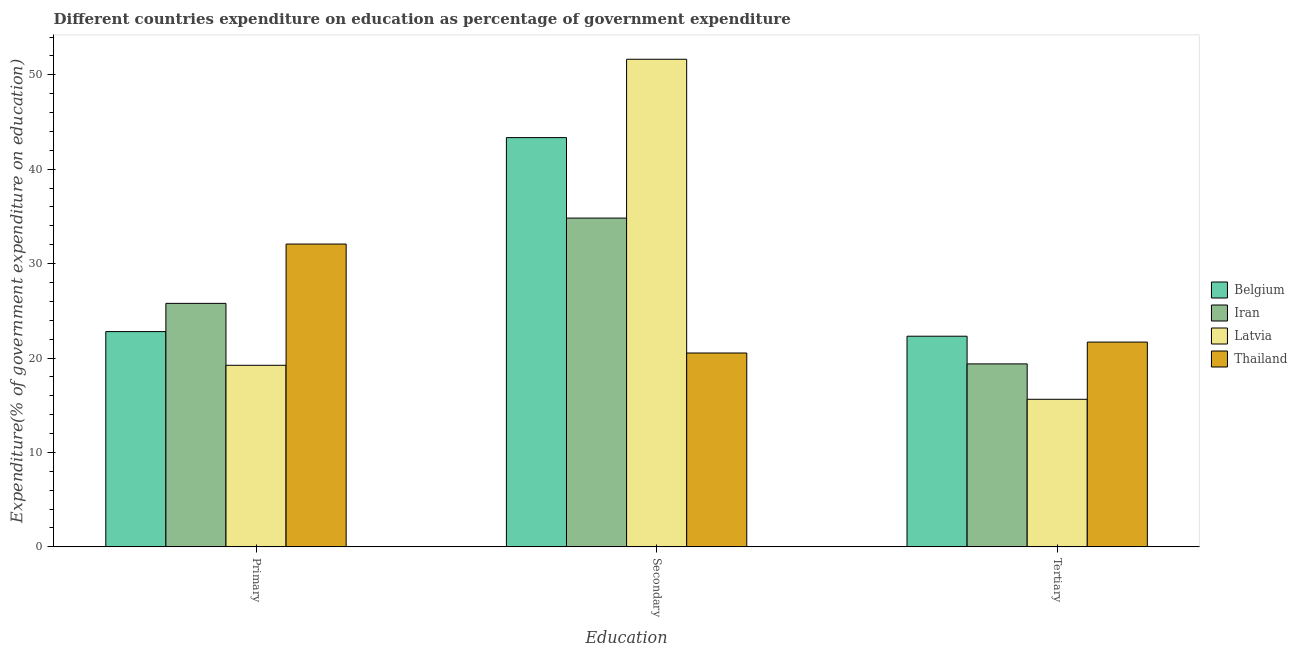How many different coloured bars are there?
Provide a short and direct response. 4. Are the number of bars on each tick of the X-axis equal?
Your answer should be compact. Yes. How many bars are there on the 2nd tick from the left?
Give a very brief answer. 4. How many bars are there on the 2nd tick from the right?
Your answer should be very brief. 4. What is the label of the 2nd group of bars from the left?
Give a very brief answer. Secondary. What is the expenditure on secondary education in Latvia?
Ensure brevity in your answer.  51.64. Across all countries, what is the maximum expenditure on tertiary education?
Provide a succinct answer. 22.31. Across all countries, what is the minimum expenditure on secondary education?
Your answer should be very brief. 20.53. In which country was the expenditure on secondary education maximum?
Give a very brief answer. Latvia. In which country was the expenditure on secondary education minimum?
Your answer should be compact. Thailand. What is the total expenditure on secondary education in the graph?
Ensure brevity in your answer.  150.34. What is the difference between the expenditure on secondary education in Latvia and that in Thailand?
Your answer should be compact. 31.11. What is the difference between the expenditure on tertiary education in Belgium and the expenditure on primary education in Iran?
Keep it short and to the point. -3.48. What is the average expenditure on primary education per country?
Provide a short and direct response. 24.97. What is the difference between the expenditure on tertiary education and expenditure on primary education in Iran?
Provide a short and direct response. -6.41. What is the ratio of the expenditure on primary education in Latvia to that in Thailand?
Provide a succinct answer. 0.6. Is the expenditure on tertiary education in Belgium less than that in Iran?
Give a very brief answer. No. What is the difference between the highest and the second highest expenditure on primary education?
Ensure brevity in your answer.  6.28. What is the difference between the highest and the lowest expenditure on primary education?
Make the answer very short. 12.84. Is the sum of the expenditure on primary education in Latvia and Belgium greater than the maximum expenditure on secondary education across all countries?
Your answer should be compact. No. What does the 3rd bar from the left in Secondary represents?
Provide a short and direct response. Latvia. What does the 1st bar from the right in Secondary represents?
Give a very brief answer. Thailand. How many bars are there?
Provide a succinct answer. 12. How many countries are there in the graph?
Keep it short and to the point. 4. What is the difference between two consecutive major ticks on the Y-axis?
Make the answer very short. 10. Are the values on the major ticks of Y-axis written in scientific E-notation?
Ensure brevity in your answer.  No. Does the graph contain any zero values?
Offer a very short reply. No. Does the graph contain grids?
Keep it short and to the point. No. How many legend labels are there?
Ensure brevity in your answer.  4. How are the legend labels stacked?
Your answer should be compact. Vertical. What is the title of the graph?
Your response must be concise. Different countries expenditure on education as percentage of government expenditure. Does "Costa Rica" appear as one of the legend labels in the graph?
Keep it short and to the point. No. What is the label or title of the X-axis?
Your answer should be very brief. Education. What is the label or title of the Y-axis?
Your response must be concise. Expenditure(% of government expenditure on education). What is the Expenditure(% of government expenditure on education) in Belgium in Primary?
Offer a terse response. 22.8. What is the Expenditure(% of government expenditure on education) of Iran in Primary?
Ensure brevity in your answer.  25.79. What is the Expenditure(% of government expenditure on education) in Latvia in Primary?
Your answer should be compact. 19.23. What is the Expenditure(% of government expenditure on education) in Thailand in Primary?
Your answer should be very brief. 32.07. What is the Expenditure(% of government expenditure on education) in Belgium in Secondary?
Provide a short and direct response. 43.35. What is the Expenditure(% of government expenditure on education) in Iran in Secondary?
Your answer should be very brief. 34.82. What is the Expenditure(% of government expenditure on education) of Latvia in Secondary?
Your answer should be compact. 51.64. What is the Expenditure(% of government expenditure on education) in Thailand in Secondary?
Provide a short and direct response. 20.53. What is the Expenditure(% of government expenditure on education) of Belgium in Tertiary?
Provide a succinct answer. 22.31. What is the Expenditure(% of government expenditure on education) of Iran in Tertiary?
Offer a very short reply. 19.38. What is the Expenditure(% of government expenditure on education) of Latvia in Tertiary?
Offer a very short reply. 15.63. What is the Expenditure(% of government expenditure on education) in Thailand in Tertiary?
Your answer should be compact. 21.69. Across all Education, what is the maximum Expenditure(% of government expenditure on education) of Belgium?
Provide a succinct answer. 43.35. Across all Education, what is the maximum Expenditure(% of government expenditure on education) in Iran?
Provide a succinct answer. 34.82. Across all Education, what is the maximum Expenditure(% of government expenditure on education) in Latvia?
Your response must be concise. 51.64. Across all Education, what is the maximum Expenditure(% of government expenditure on education) in Thailand?
Ensure brevity in your answer.  32.07. Across all Education, what is the minimum Expenditure(% of government expenditure on education) in Belgium?
Ensure brevity in your answer.  22.31. Across all Education, what is the minimum Expenditure(% of government expenditure on education) of Iran?
Give a very brief answer. 19.38. Across all Education, what is the minimum Expenditure(% of government expenditure on education) of Latvia?
Ensure brevity in your answer.  15.63. Across all Education, what is the minimum Expenditure(% of government expenditure on education) in Thailand?
Your response must be concise. 20.53. What is the total Expenditure(% of government expenditure on education) in Belgium in the graph?
Your answer should be very brief. 88.46. What is the total Expenditure(% of government expenditure on education) in Iran in the graph?
Give a very brief answer. 79.99. What is the total Expenditure(% of government expenditure on education) of Latvia in the graph?
Ensure brevity in your answer.  86.5. What is the total Expenditure(% of government expenditure on education) in Thailand in the graph?
Your response must be concise. 74.29. What is the difference between the Expenditure(% of government expenditure on education) of Belgium in Primary and that in Secondary?
Provide a short and direct response. -20.55. What is the difference between the Expenditure(% of government expenditure on education) of Iran in Primary and that in Secondary?
Make the answer very short. -9.03. What is the difference between the Expenditure(% of government expenditure on education) of Latvia in Primary and that in Secondary?
Ensure brevity in your answer.  -32.41. What is the difference between the Expenditure(% of government expenditure on education) in Thailand in Primary and that in Secondary?
Your response must be concise. 11.54. What is the difference between the Expenditure(% of government expenditure on education) in Belgium in Primary and that in Tertiary?
Your answer should be very brief. 0.49. What is the difference between the Expenditure(% of government expenditure on education) of Iran in Primary and that in Tertiary?
Your response must be concise. 6.41. What is the difference between the Expenditure(% of government expenditure on education) in Latvia in Primary and that in Tertiary?
Ensure brevity in your answer.  3.6. What is the difference between the Expenditure(% of government expenditure on education) in Thailand in Primary and that in Tertiary?
Ensure brevity in your answer.  10.38. What is the difference between the Expenditure(% of government expenditure on education) in Belgium in Secondary and that in Tertiary?
Your answer should be compact. 21.04. What is the difference between the Expenditure(% of government expenditure on education) of Iran in Secondary and that in Tertiary?
Your answer should be very brief. 15.44. What is the difference between the Expenditure(% of government expenditure on education) of Latvia in Secondary and that in Tertiary?
Offer a very short reply. 36.01. What is the difference between the Expenditure(% of government expenditure on education) of Thailand in Secondary and that in Tertiary?
Offer a very short reply. -1.16. What is the difference between the Expenditure(% of government expenditure on education) of Belgium in Primary and the Expenditure(% of government expenditure on education) of Iran in Secondary?
Make the answer very short. -12.02. What is the difference between the Expenditure(% of government expenditure on education) of Belgium in Primary and the Expenditure(% of government expenditure on education) of Latvia in Secondary?
Offer a very short reply. -28.84. What is the difference between the Expenditure(% of government expenditure on education) in Belgium in Primary and the Expenditure(% of government expenditure on education) in Thailand in Secondary?
Provide a succinct answer. 2.27. What is the difference between the Expenditure(% of government expenditure on education) of Iran in Primary and the Expenditure(% of government expenditure on education) of Latvia in Secondary?
Give a very brief answer. -25.85. What is the difference between the Expenditure(% of government expenditure on education) in Iran in Primary and the Expenditure(% of government expenditure on education) in Thailand in Secondary?
Your answer should be very brief. 5.26. What is the difference between the Expenditure(% of government expenditure on education) in Latvia in Primary and the Expenditure(% of government expenditure on education) in Thailand in Secondary?
Provide a short and direct response. -1.3. What is the difference between the Expenditure(% of government expenditure on education) in Belgium in Primary and the Expenditure(% of government expenditure on education) in Iran in Tertiary?
Ensure brevity in your answer.  3.42. What is the difference between the Expenditure(% of government expenditure on education) of Belgium in Primary and the Expenditure(% of government expenditure on education) of Latvia in Tertiary?
Make the answer very short. 7.17. What is the difference between the Expenditure(% of government expenditure on education) in Belgium in Primary and the Expenditure(% of government expenditure on education) in Thailand in Tertiary?
Provide a succinct answer. 1.11. What is the difference between the Expenditure(% of government expenditure on education) of Iran in Primary and the Expenditure(% of government expenditure on education) of Latvia in Tertiary?
Ensure brevity in your answer.  10.16. What is the difference between the Expenditure(% of government expenditure on education) in Iran in Primary and the Expenditure(% of government expenditure on education) in Thailand in Tertiary?
Provide a succinct answer. 4.1. What is the difference between the Expenditure(% of government expenditure on education) of Latvia in Primary and the Expenditure(% of government expenditure on education) of Thailand in Tertiary?
Ensure brevity in your answer.  -2.46. What is the difference between the Expenditure(% of government expenditure on education) in Belgium in Secondary and the Expenditure(% of government expenditure on education) in Iran in Tertiary?
Your answer should be compact. 23.97. What is the difference between the Expenditure(% of government expenditure on education) in Belgium in Secondary and the Expenditure(% of government expenditure on education) in Latvia in Tertiary?
Your answer should be compact. 27.72. What is the difference between the Expenditure(% of government expenditure on education) of Belgium in Secondary and the Expenditure(% of government expenditure on education) of Thailand in Tertiary?
Keep it short and to the point. 21.66. What is the difference between the Expenditure(% of government expenditure on education) of Iran in Secondary and the Expenditure(% of government expenditure on education) of Latvia in Tertiary?
Provide a succinct answer. 19.19. What is the difference between the Expenditure(% of government expenditure on education) in Iran in Secondary and the Expenditure(% of government expenditure on education) in Thailand in Tertiary?
Your response must be concise. 13.13. What is the difference between the Expenditure(% of government expenditure on education) in Latvia in Secondary and the Expenditure(% of government expenditure on education) in Thailand in Tertiary?
Keep it short and to the point. 29.96. What is the average Expenditure(% of government expenditure on education) in Belgium per Education?
Your answer should be very brief. 29.49. What is the average Expenditure(% of government expenditure on education) of Iran per Education?
Make the answer very short. 26.66. What is the average Expenditure(% of government expenditure on education) of Latvia per Education?
Keep it short and to the point. 28.83. What is the average Expenditure(% of government expenditure on education) in Thailand per Education?
Keep it short and to the point. 24.76. What is the difference between the Expenditure(% of government expenditure on education) in Belgium and Expenditure(% of government expenditure on education) in Iran in Primary?
Offer a very short reply. -2.99. What is the difference between the Expenditure(% of government expenditure on education) of Belgium and Expenditure(% of government expenditure on education) of Latvia in Primary?
Your answer should be very brief. 3.57. What is the difference between the Expenditure(% of government expenditure on education) in Belgium and Expenditure(% of government expenditure on education) in Thailand in Primary?
Offer a terse response. -9.27. What is the difference between the Expenditure(% of government expenditure on education) of Iran and Expenditure(% of government expenditure on education) of Latvia in Primary?
Your answer should be very brief. 6.56. What is the difference between the Expenditure(% of government expenditure on education) in Iran and Expenditure(% of government expenditure on education) in Thailand in Primary?
Ensure brevity in your answer.  -6.28. What is the difference between the Expenditure(% of government expenditure on education) of Latvia and Expenditure(% of government expenditure on education) of Thailand in Primary?
Give a very brief answer. -12.84. What is the difference between the Expenditure(% of government expenditure on education) of Belgium and Expenditure(% of government expenditure on education) of Iran in Secondary?
Ensure brevity in your answer.  8.52. What is the difference between the Expenditure(% of government expenditure on education) of Belgium and Expenditure(% of government expenditure on education) of Latvia in Secondary?
Give a very brief answer. -8.3. What is the difference between the Expenditure(% of government expenditure on education) of Belgium and Expenditure(% of government expenditure on education) of Thailand in Secondary?
Give a very brief answer. 22.81. What is the difference between the Expenditure(% of government expenditure on education) in Iran and Expenditure(% of government expenditure on education) in Latvia in Secondary?
Your response must be concise. -16.82. What is the difference between the Expenditure(% of government expenditure on education) of Iran and Expenditure(% of government expenditure on education) of Thailand in Secondary?
Offer a terse response. 14.29. What is the difference between the Expenditure(% of government expenditure on education) of Latvia and Expenditure(% of government expenditure on education) of Thailand in Secondary?
Offer a very short reply. 31.11. What is the difference between the Expenditure(% of government expenditure on education) of Belgium and Expenditure(% of government expenditure on education) of Iran in Tertiary?
Your answer should be compact. 2.93. What is the difference between the Expenditure(% of government expenditure on education) of Belgium and Expenditure(% of government expenditure on education) of Latvia in Tertiary?
Give a very brief answer. 6.68. What is the difference between the Expenditure(% of government expenditure on education) of Belgium and Expenditure(% of government expenditure on education) of Thailand in Tertiary?
Your answer should be compact. 0.62. What is the difference between the Expenditure(% of government expenditure on education) of Iran and Expenditure(% of government expenditure on education) of Latvia in Tertiary?
Your answer should be compact. 3.75. What is the difference between the Expenditure(% of government expenditure on education) in Iran and Expenditure(% of government expenditure on education) in Thailand in Tertiary?
Ensure brevity in your answer.  -2.31. What is the difference between the Expenditure(% of government expenditure on education) of Latvia and Expenditure(% of government expenditure on education) of Thailand in Tertiary?
Provide a short and direct response. -6.06. What is the ratio of the Expenditure(% of government expenditure on education) of Belgium in Primary to that in Secondary?
Offer a very short reply. 0.53. What is the ratio of the Expenditure(% of government expenditure on education) in Iran in Primary to that in Secondary?
Give a very brief answer. 0.74. What is the ratio of the Expenditure(% of government expenditure on education) in Latvia in Primary to that in Secondary?
Ensure brevity in your answer.  0.37. What is the ratio of the Expenditure(% of government expenditure on education) in Thailand in Primary to that in Secondary?
Give a very brief answer. 1.56. What is the ratio of the Expenditure(% of government expenditure on education) in Belgium in Primary to that in Tertiary?
Ensure brevity in your answer.  1.02. What is the ratio of the Expenditure(% of government expenditure on education) in Iran in Primary to that in Tertiary?
Keep it short and to the point. 1.33. What is the ratio of the Expenditure(% of government expenditure on education) in Latvia in Primary to that in Tertiary?
Provide a succinct answer. 1.23. What is the ratio of the Expenditure(% of government expenditure on education) of Thailand in Primary to that in Tertiary?
Make the answer very short. 1.48. What is the ratio of the Expenditure(% of government expenditure on education) in Belgium in Secondary to that in Tertiary?
Give a very brief answer. 1.94. What is the ratio of the Expenditure(% of government expenditure on education) of Iran in Secondary to that in Tertiary?
Offer a terse response. 1.8. What is the ratio of the Expenditure(% of government expenditure on education) of Latvia in Secondary to that in Tertiary?
Make the answer very short. 3.3. What is the ratio of the Expenditure(% of government expenditure on education) of Thailand in Secondary to that in Tertiary?
Provide a short and direct response. 0.95. What is the difference between the highest and the second highest Expenditure(% of government expenditure on education) in Belgium?
Provide a short and direct response. 20.55. What is the difference between the highest and the second highest Expenditure(% of government expenditure on education) in Iran?
Your response must be concise. 9.03. What is the difference between the highest and the second highest Expenditure(% of government expenditure on education) of Latvia?
Ensure brevity in your answer.  32.41. What is the difference between the highest and the second highest Expenditure(% of government expenditure on education) of Thailand?
Give a very brief answer. 10.38. What is the difference between the highest and the lowest Expenditure(% of government expenditure on education) of Belgium?
Keep it short and to the point. 21.04. What is the difference between the highest and the lowest Expenditure(% of government expenditure on education) in Iran?
Make the answer very short. 15.44. What is the difference between the highest and the lowest Expenditure(% of government expenditure on education) in Latvia?
Your answer should be compact. 36.01. What is the difference between the highest and the lowest Expenditure(% of government expenditure on education) in Thailand?
Ensure brevity in your answer.  11.54. 